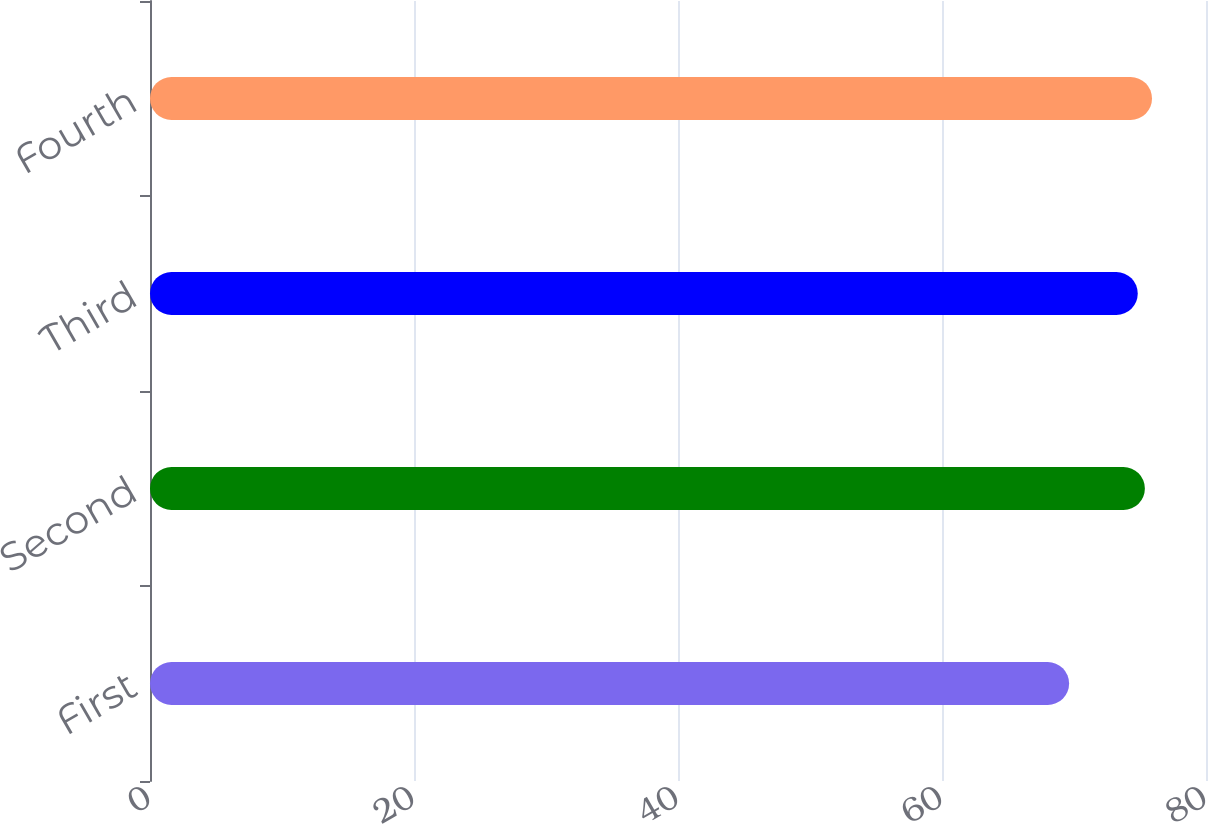<chart> <loc_0><loc_0><loc_500><loc_500><bar_chart><fcel>First<fcel>Second<fcel>Third<fcel>Fourth<nl><fcel>69.63<fcel>75.37<fcel>74.83<fcel>75.91<nl></chart> 